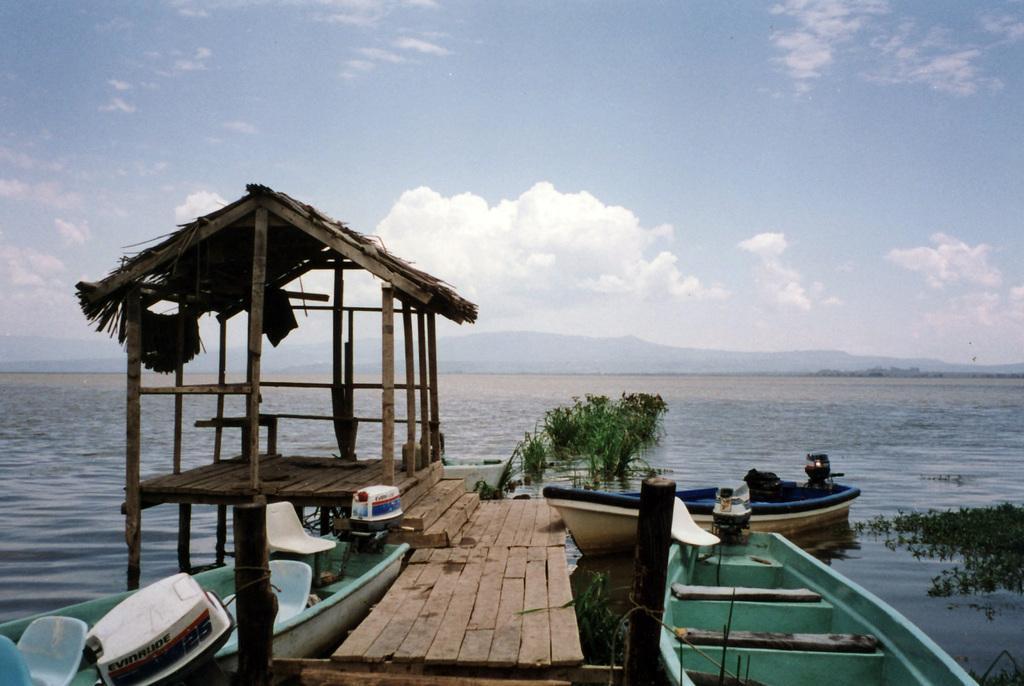Can you describe this image briefly? In this picture I can observe beach shed on the left side. In the bottom of the picture I can observe wooden platform. On the right side I can observe boats and plants in the water. In the background I can observe clouds in the sky. 